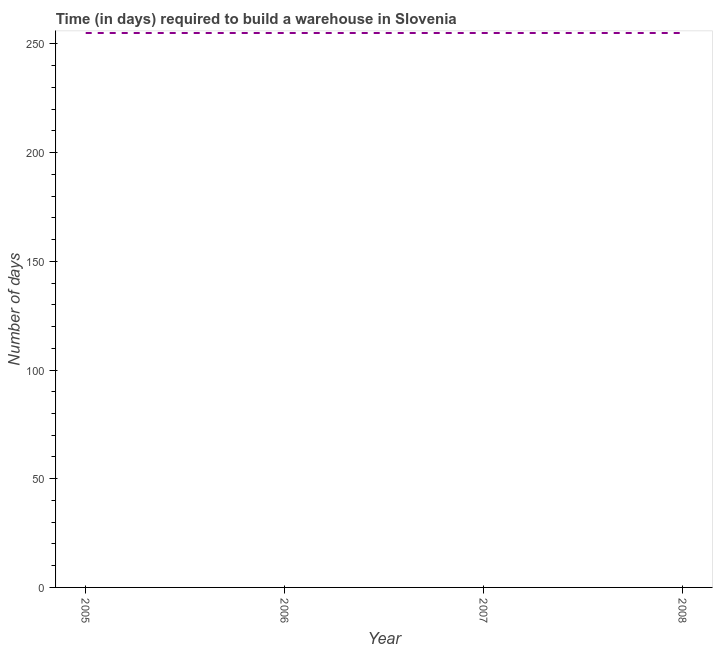What is the time required to build a warehouse in 2007?
Your answer should be compact. 255. Across all years, what is the maximum time required to build a warehouse?
Ensure brevity in your answer.  255. Across all years, what is the minimum time required to build a warehouse?
Your answer should be very brief. 255. In which year was the time required to build a warehouse maximum?
Offer a terse response. 2005. What is the sum of the time required to build a warehouse?
Your answer should be compact. 1020. What is the average time required to build a warehouse per year?
Keep it short and to the point. 255. What is the median time required to build a warehouse?
Give a very brief answer. 255. In how many years, is the time required to build a warehouse greater than 10 days?
Offer a terse response. 4. Is the time required to build a warehouse in 2006 less than that in 2007?
Offer a very short reply. No. How many years are there in the graph?
Make the answer very short. 4. What is the difference between two consecutive major ticks on the Y-axis?
Your answer should be very brief. 50. Does the graph contain grids?
Keep it short and to the point. No. What is the title of the graph?
Give a very brief answer. Time (in days) required to build a warehouse in Slovenia. What is the label or title of the Y-axis?
Offer a terse response. Number of days. What is the Number of days of 2005?
Your answer should be compact. 255. What is the Number of days in 2006?
Your response must be concise. 255. What is the Number of days in 2007?
Keep it short and to the point. 255. What is the Number of days in 2008?
Provide a short and direct response. 255. What is the difference between the Number of days in 2005 and 2006?
Keep it short and to the point. 0. What is the difference between the Number of days in 2005 and 2007?
Ensure brevity in your answer.  0. What is the difference between the Number of days in 2005 and 2008?
Make the answer very short. 0. What is the difference between the Number of days in 2006 and 2007?
Provide a succinct answer. 0. What is the difference between the Number of days in 2006 and 2008?
Offer a terse response. 0. What is the difference between the Number of days in 2007 and 2008?
Make the answer very short. 0. What is the ratio of the Number of days in 2005 to that in 2007?
Offer a terse response. 1. 